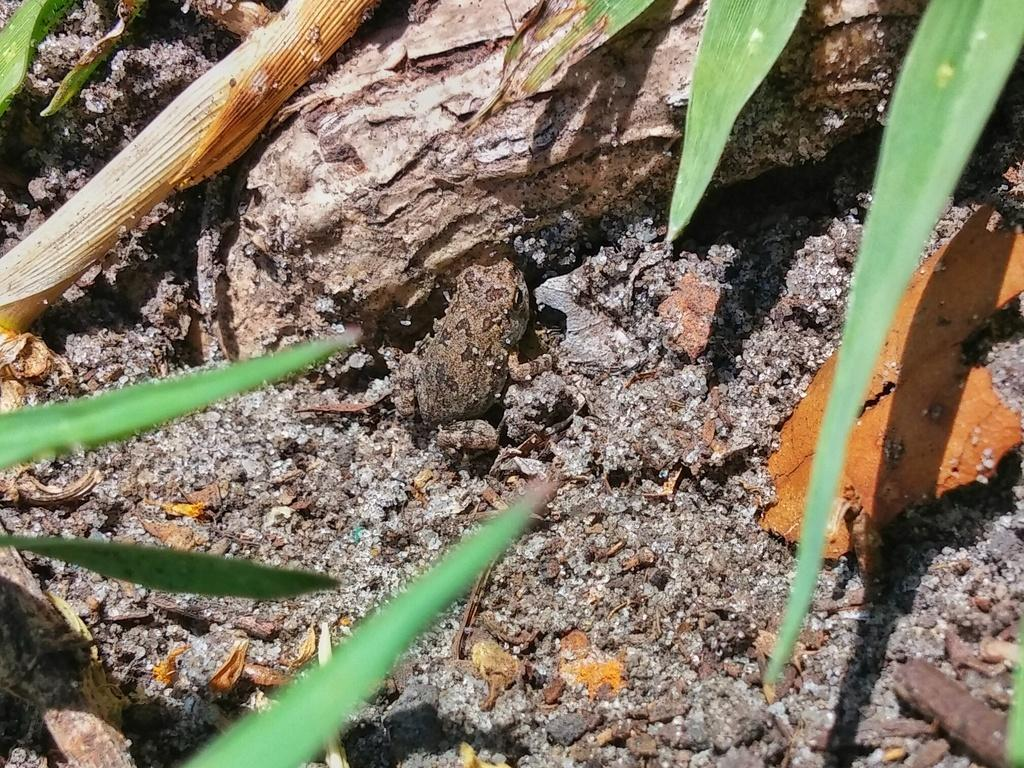What type of animal is in the image? There is a frog in the image. What type of vegetation is in the image? There are leaves in the image. Can you describe any other objects in the image? There are some unspecified objects in the image. What news is the frog reporting in the image? There is no indication in the image that the frog is reporting any news. 